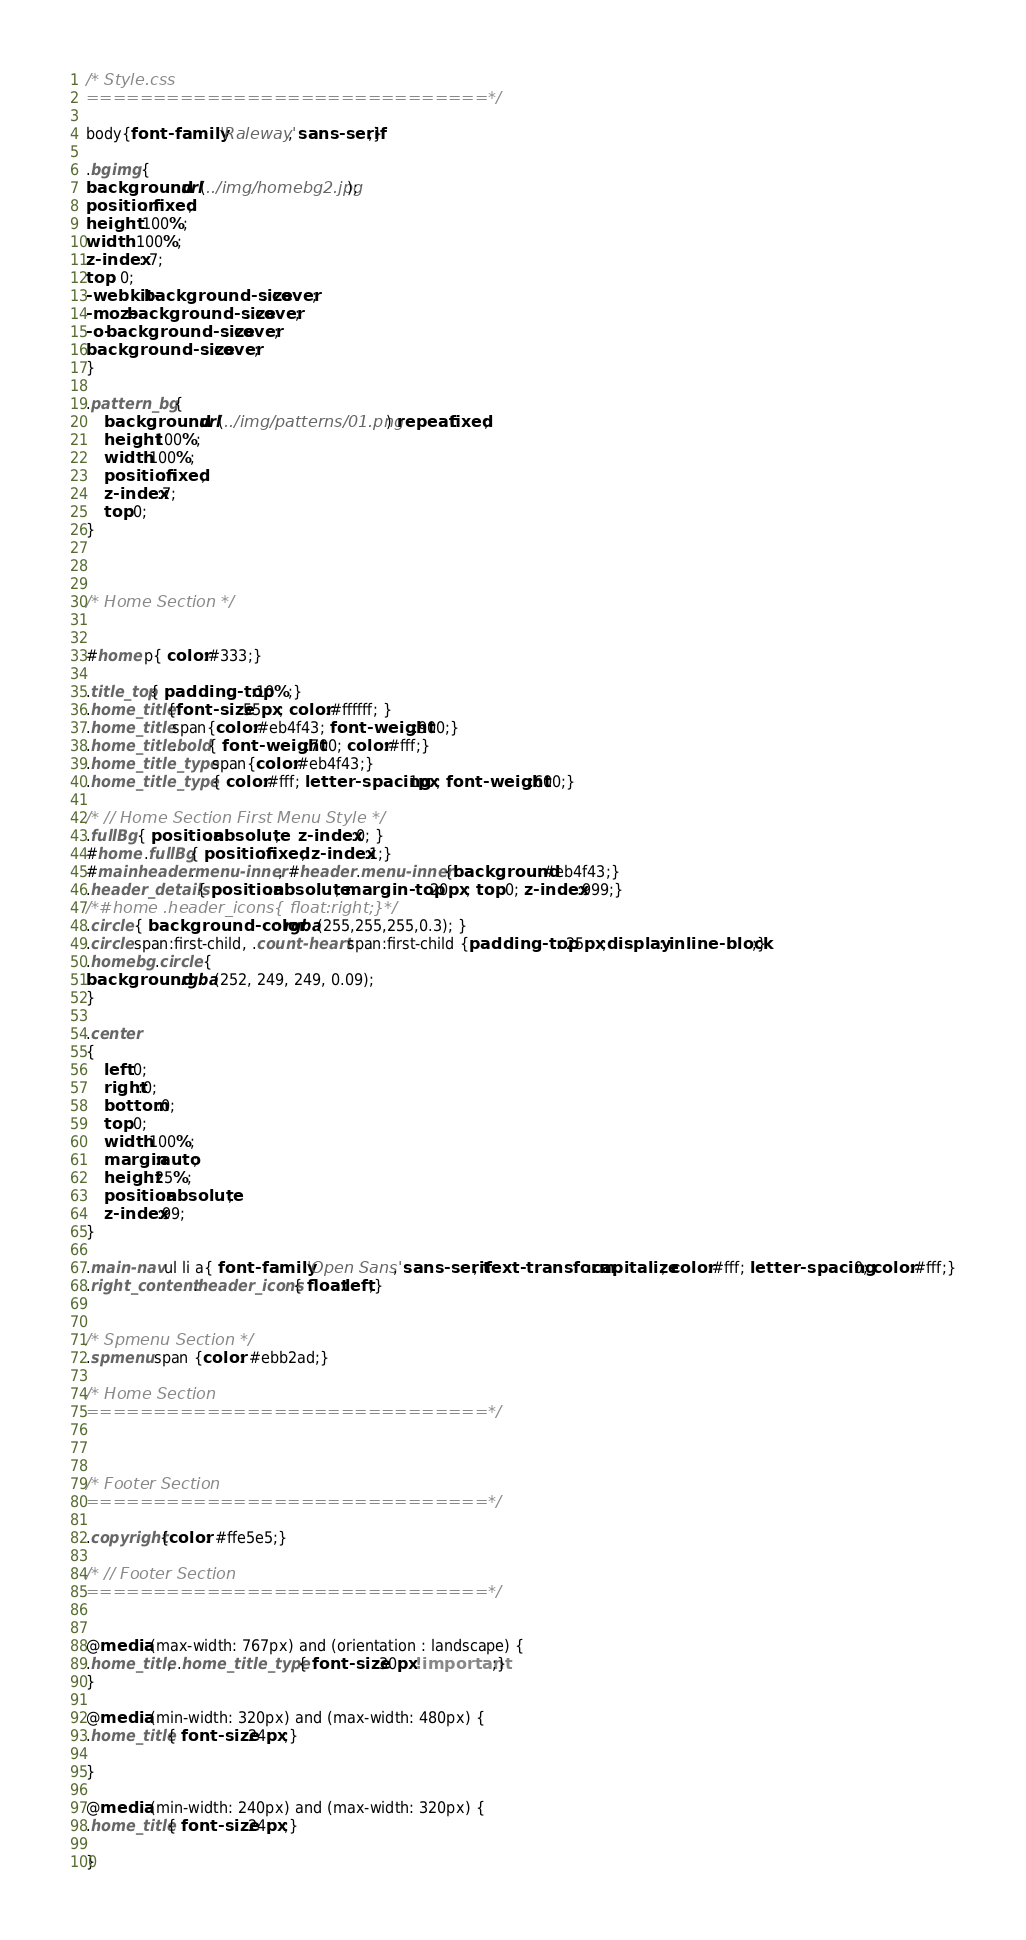Convert code to text. <code><loc_0><loc_0><loc_500><loc_500><_CSS_>
/* Style.css
==============================*/

body{font-family: 'Raleway', sans-serif;}

.bgimg {
background: url(../img/homebg2.jpg);
position: fixed;
height: 100%;
width: 100%;
z-index: 7;
top: 0;
-webkit-background-size: cover;
-moz-background-size: cover;
-o-background-size: cover;
background-size: cover;
}

.pattern_bg {
	background: url(../img/patterns/01.png) repeat fixed;
	height:100%;
	width:100%;
	position:fixed;
	z-index:7;
	top:0;
}



/* Home Section */	


#home p{ color:#333;}

.title_top{ padding-top:10%;}
.home_title{font-size:55px; color:#ffffff; }
.home_title span{color:#eb4f43; font-weight:900;}
.home_title .bold{ font-weight:700; color:#fff;}
.home_title_type span{color:#eb4f43;}
.home_title_type { color:#fff; letter-spacing:1px; font-weight:600;}

/* // Home Section First Menu Style */
.fullBg { position:absolute;	z-index:0; }
#home .fullBg{ position:fixed; z-index:1;}
#mainheader .menu-inner, #header .menu-inner{background:#eb4f43;}
.header_details{ position:absolute; margin-top:20px; top:0; z-index:999;}
/*#home .header_icons{ float:right;}*/
.circle { background-color: rgba(255,255,255,0.3); }
.circle span:first-child, .count-heart span:first-child {padding-top: 25px;display: inline-block;}
.homebg .circle {
background: rgba(252, 249, 249, 0.09);
}

.center
{
	left:0;
	right:0;
	bottom:0;
	top:0;
	width:100%;
	margin:auto;
	height:25%;
	position:absolute;
	z-index:99;
}

.main-nav ul li a{ font-family: 'Open Sans', sans-serif; text-transform:capitalize; color:#fff; letter-spacing:0; color:#fff;}
.right_content .header_icons{ float:left;}


/* Spmenu Section */	
.spmenu span {color: #ebb2ad;}

/* Home Section
==============================*/



/* Footer Section
==============================*/

.copyright{color: #ffe5e5;}

/* // Footer Section
==============================*/


@media (max-width: 767px) and (orientation : landscape) {
.home_title, .home_title_type{ font-size:30px!important;}
}

@media (min-width: 320px) and (max-width: 480px) {
.home_title{ font-size:24px;}

}

@media (min-width: 240px) and (max-width: 320px) {
.home_title{ font-size:24px;}

}
</code> 